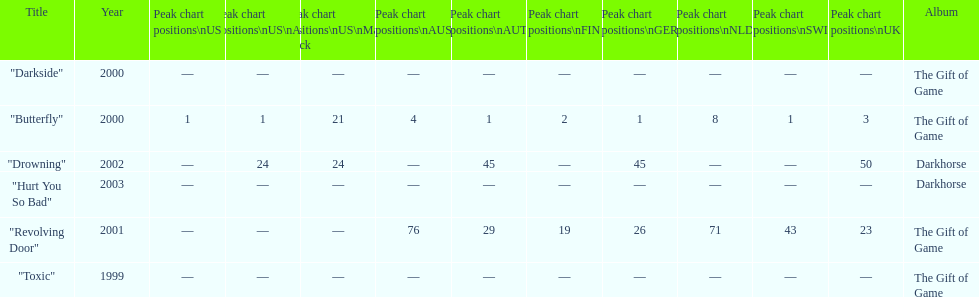When did "drowning" peak at 24 in the us alternate group? 2002. 